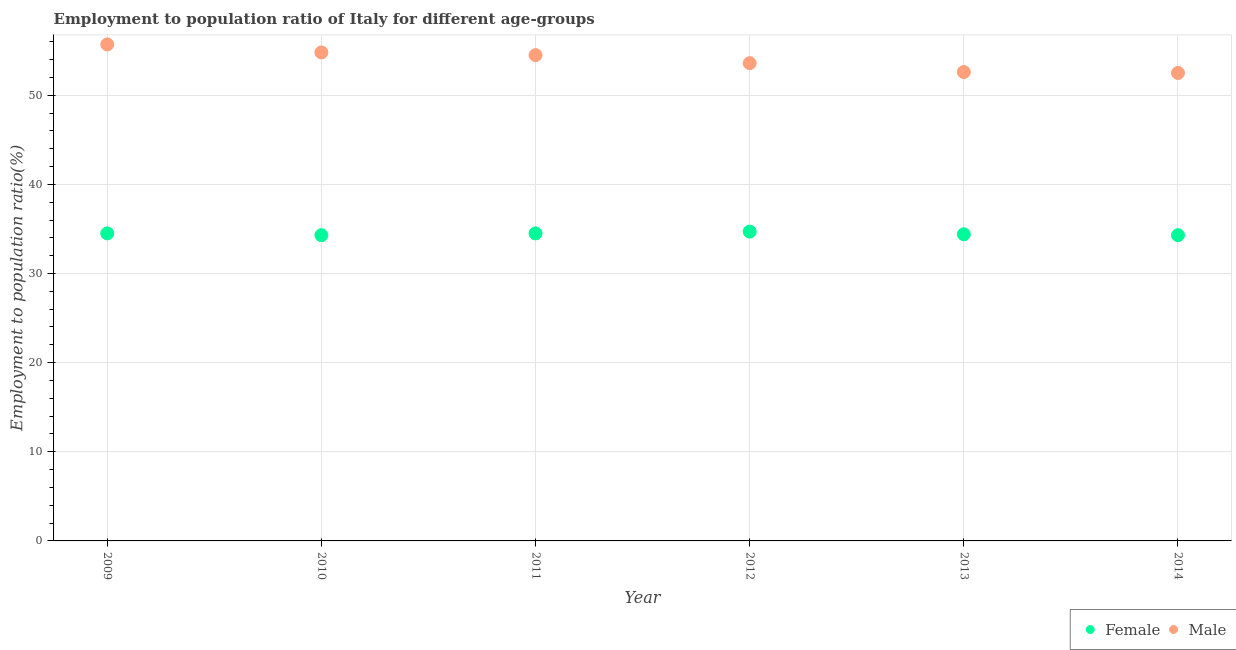Is the number of dotlines equal to the number of legend labels?
Offer a terse response. Yes. What is the employment to population ratio(male) in 2010?
Ensure brevity in your answer.  54.8. Across all years, what is the maximum employment to population ratio(female)?
Your response must be concise. 34.7. Across all years, what is the minimum employment to population ratio(male)?
Ensure brevity in your answer.  52.5. In which year was the employment to population ratio(female) maximum?
Provide a short and direct response. 2012. In which year was the employment to population ratio(male) minimum?
Offer a terse response. 2014. What is the total employment to population ratio(male) in the graph?
Your response must be concise. 323.7. What is the difference between the employment to population ratio(male) in 2010 and that in 2014?
Offer a very short reply. 2.3. What is the difference between the employment to population ratio(female) in 2014 and the employment to population ratio(male) in 2012?
Your response must be concise. -19.3. What is the average employment to population ratio(male) per year?
Ensure brevity in your answer.  53.95. In the year 2010, what is the difference between the employment to population ratio(female) and employment to population ratio(male)?
Provide a succinct answer. -20.5. In how many years, is the employment to population ratio(male) greater than 28 %?
Make the answer very short. 6. What is the ratio of the employment to population ratio(male) in 2012 to that in 2013?
Offer a very short reply. 1.02. Is the employment to population ratio(male) in 2010 less than that in 2013?
Make the answer very short. No. What is the difference between the highest and the second highest employment to population ratio(male)?
Provide a succinct answer. 0.9. What is the difference between the highest and the lowest employment to population ratio(female)?
Ensure brevity in your answer.  0.4. Is the employment to population ratio(male) strictly greater than the employment to population ratio(female) over the years?
Give a very brief answer. Yes. How many dotlines are there?
Your answer should be very brief. 2. What is the difference between two consecutive major ticks on the Y-axis?
Your answer should be compact. 10. Are the values on the major ticks of Y-axis written in scientific E-notation?
Offer a very short reply. No. Does the graph contain any zero values?
Your answer should be very brief. No. Does the graph contain grids?
Give a very brief answer. Yes. What is the title of the graph?
Provide a succinct answer. Employment to population ratio of Italy for different age-groups. What is the label or title of the X-axis?
Your answer should be compact. Year. What is the label or title of the Y-axis?
Keep it short and to the point. Employment to population ratio(%). What is the Employment to population ratio(%) in Female in 2009?
Your answer should be compact. 34.5. What is the Employment to population ratio(%) in Male in 2009?
Your answer should be compact. 55.7. What is the Employment to population ratio(%) in Female in 2010?
Provide a succinct answer. 34.3. What is the Employment to population ratio(%) in Male in 2010?
Give a very brief answer. 54.8. What is the Employment to population ratio(%) of Female in 2011?
Offer a terse response. 34.5. What is the Employment to population ratio(%) in Male in 2011?
Provide a short and direct response. 54.5. What is the Employment to population ratio(%) of Female in 2012?
Provide a succinct answer. 34.7. What is the Employment to population ratio(%) of Male in 2012?
Offer a terse response. 53.6. What is the Employment to population ratio(%) in Female in 2013?
Ensure brevity in your answer.  34.4. What is the Employment to population ratio(%) of Male in 2013?
Provide a succinct answer. 52.6. What is the Employment to population ratio(%) in Female in 2014?
Offer a very short reply. 34.3. What is the Employment to population ratio(%) in Male in 2014?
Offer a terse response. 52.5. Across all years, what is the maximum Employment to population ratio(%) of Female?
Offer a terse response. 34.7. Across all years, what is the maximum Employment to population ratio(%) of Male?
Provide a succinct answer. 55.7. Across all years, what is the minimum Employment to population ratio(%) of Female?
Provide a short and direct response. 34.3. Across all years, what is the minimum Employment to population ratio(%) in Male?
Offer a terse response. 52.5. What is the total Employment to population ratio(%) of Female in the graph?
Offer a terse response. 206.7. What is the total Employment to population ratio(%) in Male in the graph?
Provide a succinct answer. 323.7. What is the difference between the Employment to population ratio(%) of Male in 2009 and that in 2010?
Provide a short and direct response. 0.9. What is the difference between the Employment to population ratio(%) in Female in 2009 and that in 2011?
Keep it short and to the point. 0. What is the difference between the Employment to population ratio(%) of Male in 2009 and that in 2014?
Your answer should be compact. 3.2. What is the difference between the Employment to population ratio(%) in Female in 2010 and that in 2011?
Your answer should be very brief. -0.2. What is the difference between the Employment to population ratio(%) of Female in 2010 and that in 2012?
Your answer should be compact. -0.4. What is the difference between the Employment to population ratio(%) of Male in 2010 and that in 2012?
Provide a succinct answer. 1.2. What is the difference between the Employment to population ratio(%) of Female in 2010 and that in 2013?
Offer a very short reply. -0.1. What is the difference between the Employment to population ratio(%) in Male in 2010 and that in 2014?
Give a very brief answer. 2.3. What is the difference between the Employment to population ratio(%) of Female in 2011 and that in 2012?
Provide a succinct answer. -0.2. What is the difference between the Employment to population ratio(%) of Male in 2011 and that in 2012?
Offer a very short reply. 0.9. What is the difference between the Employment to population ratio(%) of Male in 2011 and that in 2013?
Give a very brief answer. 1.9. What is the difference between the Employment to population ratio(%) in Male in 2012 and that in 2013?
Ensure brevity in your answer.  1. What is the difference between the Employment to population ratio(%) in Female in 2012 and that in 2014?
Keep it short and to the point. 0.4. What is the difference between the Employment to population ratio(%) in Male in 2012 and that in 2014?
Give a very brief answer. 1.1. What is the difference between the Employment to population ratio(%) in Female in 2013 and that in 2014?
Keep it short and to the point. 0.1. What is the difference between the Employment to population ratio(%) of Male in 2013 and that in 2014?
Ensure brevity in your answer.  0.1. What is the difference between the Employment to population ratio(%) of Female in 2009 and the Employment to population ratio(%) of Male in 2010?
Your answer should be compact. -20.3. What is the difference between the Employment to population ratio(%) in Female in 2009 and the Employment to population ratio(%) in Male in 2011?
Offer a terse response. -20. What is the difference between the Employment to population ratio(%) of Female in 2009 and the Employment to population ratio(%) of Male in 2012?
Your response must be concise. -19.1. What is the difference between the Employment to population ratio(%) in Female in 2009 and the Employment to population ratio(%) in Male in 2013?
Offer a very short reply. -18.1. What is the difference between the Employment to population ratio(%) of Female in 2010 and the Employment to population ratio(%) of Male in 2011?
Give a very brief answer. -20.2. What is the difference between the Employment to population ratio(%) of Female in 2010 and the Employment to population ratio(%) of Male in 2012?
Keep it short and to the point. -19.3. What is the difference between the Employment to population ratio(%) in Female in 2010 and the Employment to population ratio(%) in Male in 2013?
Provide a short and direct response. -18.3. What is the difference between the Employment to population ratio(%) in Female in 2010 and the Employment to population ratio(%) in Male in 2014?
Offer a terse response. -18.2. What is the difference between the Employment to population ratio(%) of Female in 2011 and the Employment to population ratio(%) of Male in 2012?
Offer a terse response. -19.1. What is the difference between the Employment to population ratio(%) in Female in 2011 and the Employment to population ratio(%) in Male in 2013?
Keep it short and to the point. -18.1. What is the difference between the Employment to population ratio(%) of Female in 2012 and the Employment to population ratio(%) of Male in 2013?
Offer a terse response. -17.9. What is the difference between the Employment to population ratio(%) of Female in 2012 and the Employment to population ratio(%) of Male in 2014?
Ensure brevity in your answer.  -17.8. What is the difference between the Employment to population ratio(%) of Female in 2013 and the Employment to population ratio(%) of Male in 2014?
Provide a short and direct response. -18.1. What is the average Employment to population ratio(%) of Female per year?
Offer a terse response. 34.45. What is the average Employment to population ratio(%) in Male per year?
Provide a short and direct response. 53.95. In the year 2009, what is the difference between the Employment to population ratio(%) of Female and Employment to population ratio(%) of Male?
Give a very brief answer. -21.2. In the year 2010, what is the difference between the Employment to population ratio(%) of Female and Employment to population ratio(%) of Male?
Your answer should be very brief. -20.5. In the year 2012, what is the difference between the Employment to population ratio(%) in Female and Employment to population ratio(%) in Male?
Keep it short and to the point. -18.9. In the year 2013, what is the difference between the Employment to population ratio(%) of Female and Employment to population ratio(%) of Male?
Provide a succinct answer. -18.2. In the year 2014, what is the difference between the Employment to population ratio(%) in Female and Employment to population ratio(%) in Male?
Give a very brief answer. -18.2. What is the ratio of the Employment to population ratio(%) in Male in 2009 to that in 2010?
Make the answer very short. 1.02. What is the ratio of the Employment to population ratio(%) in Male in 2009 to that in 2011?
Keep it short and to the point. 1.02. What is the ratio of the Employment to population ratio(%) of Male in 2009 to that in 2012?
Give a very brief answer. 1.04. What is the ratio of the Employment to population ratio(%) of Male in 2009 to that in 2013?
Your response must be concise. 1.06. What is the ratio of the Employment to population ratio(%) of Male in 2009 to that in 2014?
Offer a terse response. 1.06. What is the ratio of the Employment to population ratio(%) in Male in 2010 to that in 2011?
Keep it short and to the point. 1.01. What is the ratio of the Employment to population ratio(%) of Female in 2010 to that in 2012?
Ensure brevity in your answer.  0.99. What is the ratio of the Employment to population ratio(%) in Male in 2010 to that in 2012?
Your answer should be compact. 1.02. What is the ratio of the Employment to population ratio(%) in Female in 2010 to that in 2013?
Provide a succinct answer. 1. What is the ratio of the Employment to population ratio(%) of Male in 2010 to that in 2013?
Give a very brief answer. 1.04. What is the ratio of the Employment to population ratio(%) in Male in 2010 to that in 2014?
Provide a succinct answer. 1.04. What is the ratio of the Employment to population ratio(%) in Male in 2011 to that in 2012?
Offer a terse response. 1.02. What is the ratio of the Employment to population ratio(%) of Female in 2011 to that in 2013?
Make the answer very short. 1. What is the ratio of the Employment to population ratio(%) in Male in 2011 to that in 2013?
Make the answer very short. 1.04. What is the ratio of the Employment to population ratio(%) of Female in 2011 to that in 2014?
Your answer should be compact. 1.01. What is the ratio of the Employment to population ratio(%) of Male in 2011 to that in 2014?
Ensure brevity in your answer.  1.04. What is the ratio of the Employment to population ratio(%) in Female in 2012 to that in 2013?
Offer a very short reply. 1.01. What is the ratio of the Employment to population ratio(%) of Female in 2012 to that in 2014?
Offer a terse response. 1.01. What is the ratio of the Employment to population ratio(%) in Female in 2013 to that in 2014?
Offer a terse response. 1. What is the ratio of the Employment to population ratio(%) of Male in 2013 to that in 2014?
Keep it short and to the point. 1. What is the difference between the highest and the second highest Employment to population ratio(%) in Female?
Offer a terse response. 0.2. What is the difference between the highest and the second highest Employment to population ratio(%) in Male?
Make the answer very short. 0.9. What is the difference between the highest and the lowest Employment to population ratio(%) in Female?
Offer a very short reply. 0.4. What is the difference between the highest and the lowest Employment to population ratio(%) of Male?
Give a very brief answer. 3.2. 